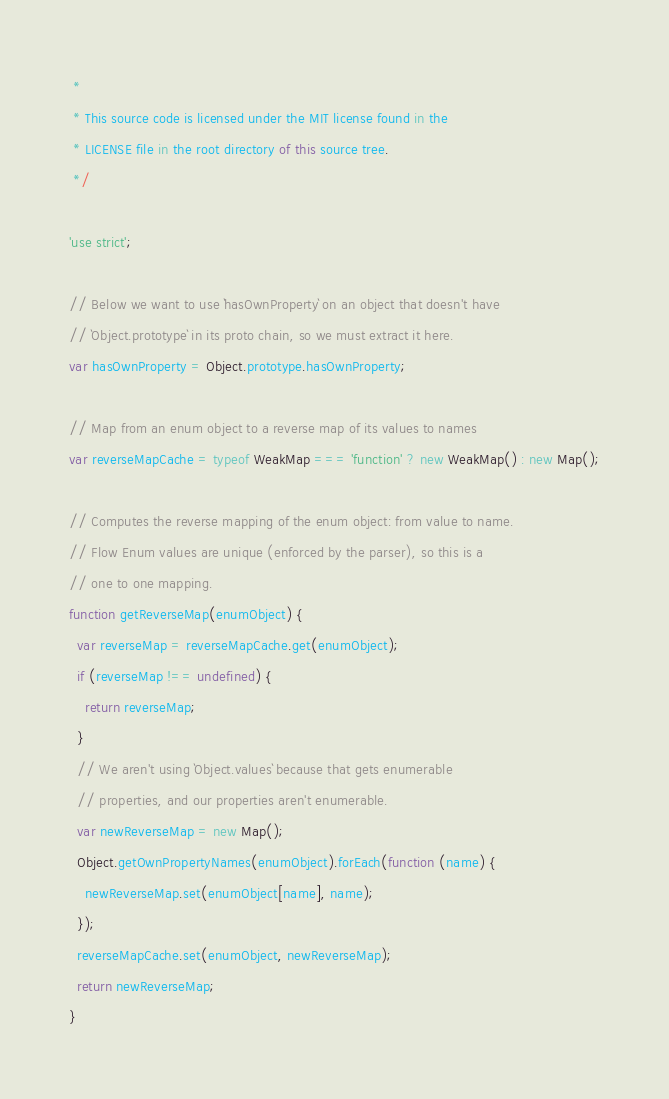Convert code to text. <code><loc_0><loc_0><loc_500><loc_500><_JavaScript_> *
 * This source code is licensed under the MIT license found in the
 * LICENSE file in the root directory of this source tree.
 */

'use strict';

// Below we want to use `hasOwnProperty` on an object that doesn't have
// `Object.prototype` in its proto chain, so we must extract it here.
var hasOwnProperty = Object.prototype.hasOwnProperty;

// Map from an enum object to a reverse map of its values to names
var reverseMapCache = typeof WeakMap === 'function' ? new WeakMap() : new Map();

// Computes the reverse mapping of the enum object: from value to name.
// Flow Enum values are unique (enforced by the parser), so this is a
// one to one mapping.
function getReverseMap(enumObject) {
  var reverseMap = reverseMapCache.get(enumObject);
  if (reverseMap !== undefined) {
    return reverseMap;
  }
  // We aren't using `Object.values` because that gets enumerable
  // properties, and our properties aren't enumerable.
  var newReverseMap = new Map();
  Object.getOwnPropertyNames(enumObject).forEach(function (name) {
    newReverseMap.set(enumObject[name], name);
  });
  reverseMapCache.set(enumObject, newReverseMap);
  return newReverseMap;
}
</code> 